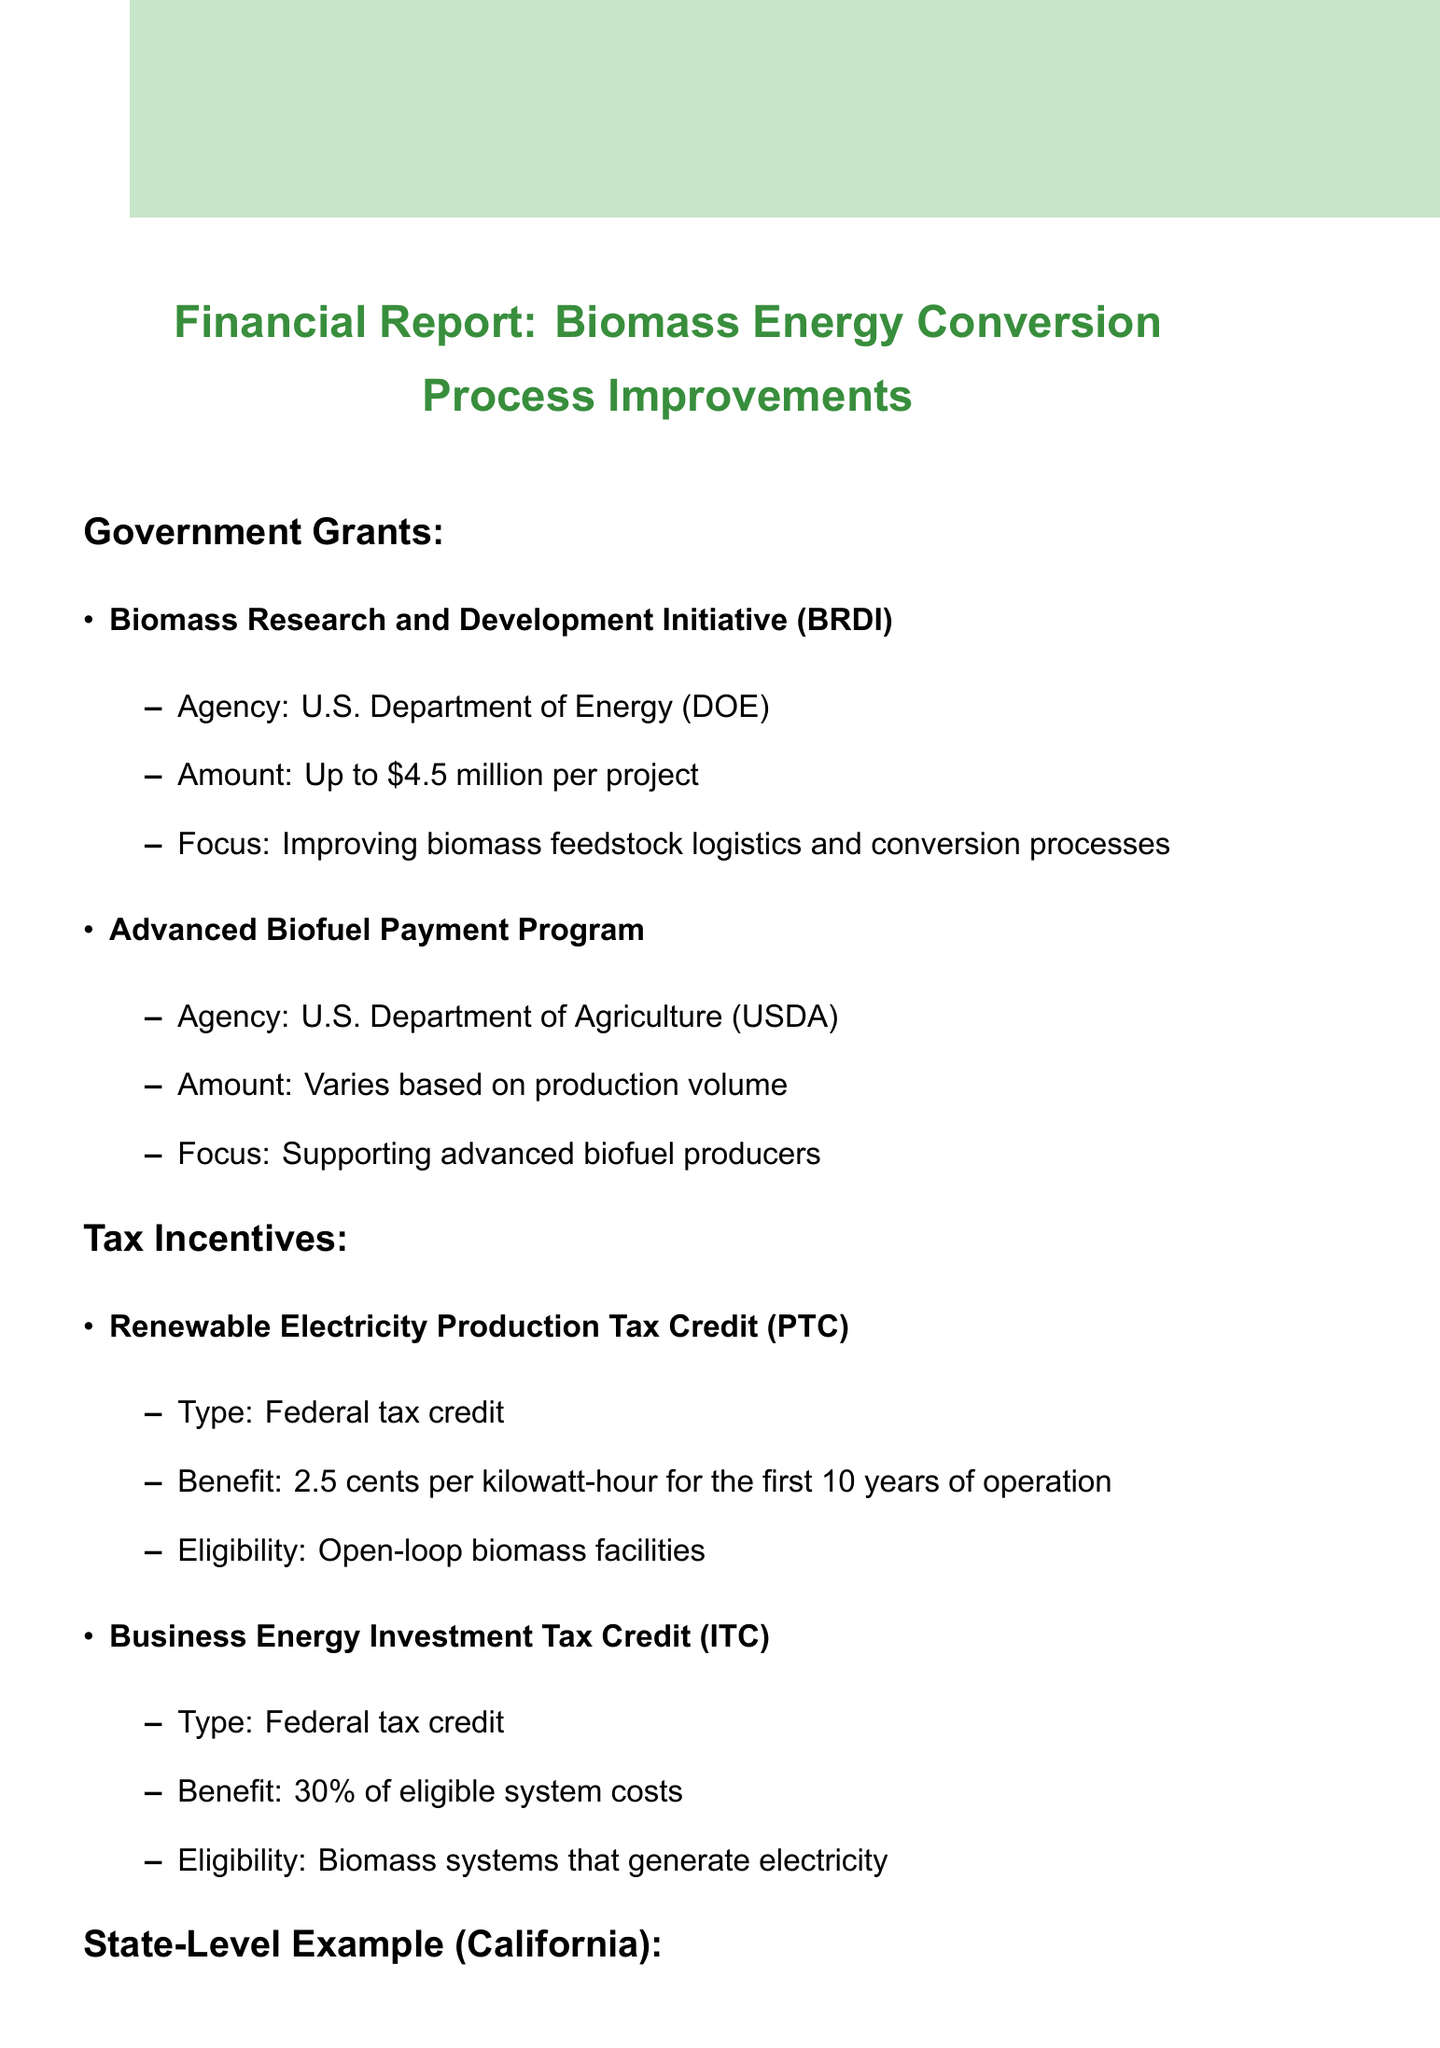What is the maximum grant amount from BRDI? The maximum grant amount offered by the Biomass Research and Development Initiative (BRDI) is stated in the document.
Answer: Up to $4.5 million per project What agency administers the Advanced Biofuel Payment Program? The agency responsible for administering the Advanced Biofuel Payment Program is specified in the document.
Answer: U.S. Department of Agriculture (USDA) How much is the Renewable Electricity Production Tax Credit? The amount of the Renewable Electricity Production Tax Credit is mentioned as a benefit in the document.
Answer: 2.5 cents per kilowatt-hour What is the eligibility criterion for the Business Energy Investment Tax Credit? The document specifies the eligibility for the Business Energy Investment Tax Credit.
Answer: Biomass systems that generate electricity What is the benefit of the Self-Generation Incentive Program? The financial benefit provided by the Self-Generation Incentive Program is detailed in the document.
Answer: Up to $2.00/W for eligible biomass projects What are key considerations in the application process? The document outlines key considerations when applying for grants and incentives.
Answer: Project timeline alignment with grant deadlines What is a potential financial benefit of applying for government grants? The document lists potential financial benefits associated with grants.
Answer: Increased profitability through tax savings What is one of the risks mentioned in the financial impact section? The risks listed in the financial impact section of the document include various aspects.
Answer: Dependency on government policies 